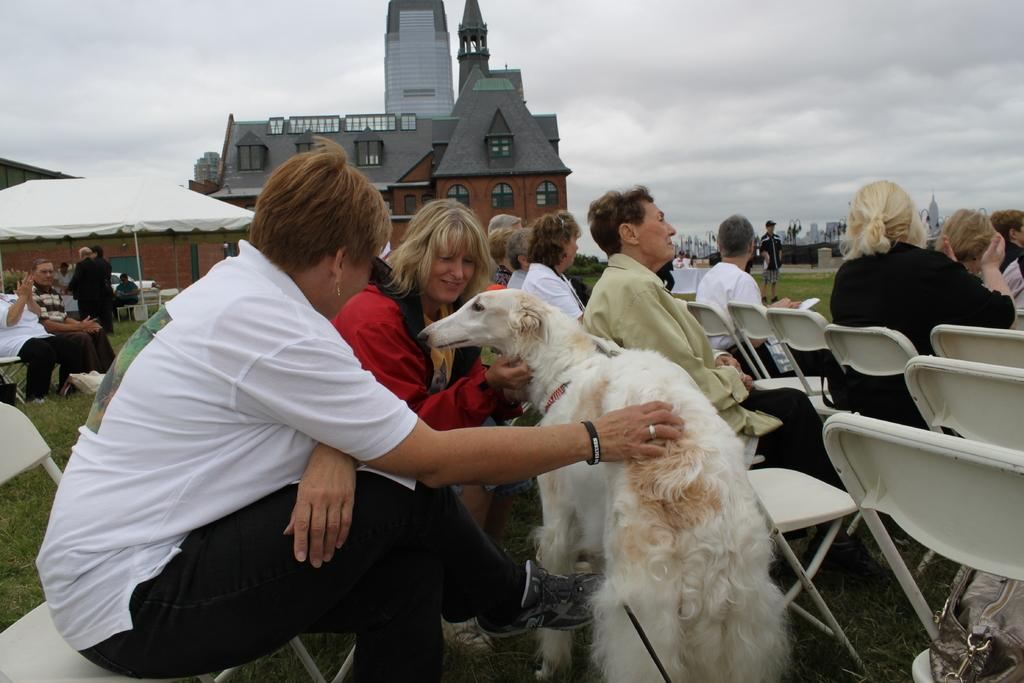What is the main activity of the people in the image? There is a group of people sitting in chairs. Can you describe the individuals in the image? Two women are sitting in the chairs, and they are holding a dog. What can be seen in the background of the image? There is a building, a tree, an umbrella, and the sky visible in the background. What type of banana is being used as a prop in the image? There is no banana present in the image. What kind of drug is being distributed by the women in the image? There is no mention or indication of any drug in the image. 